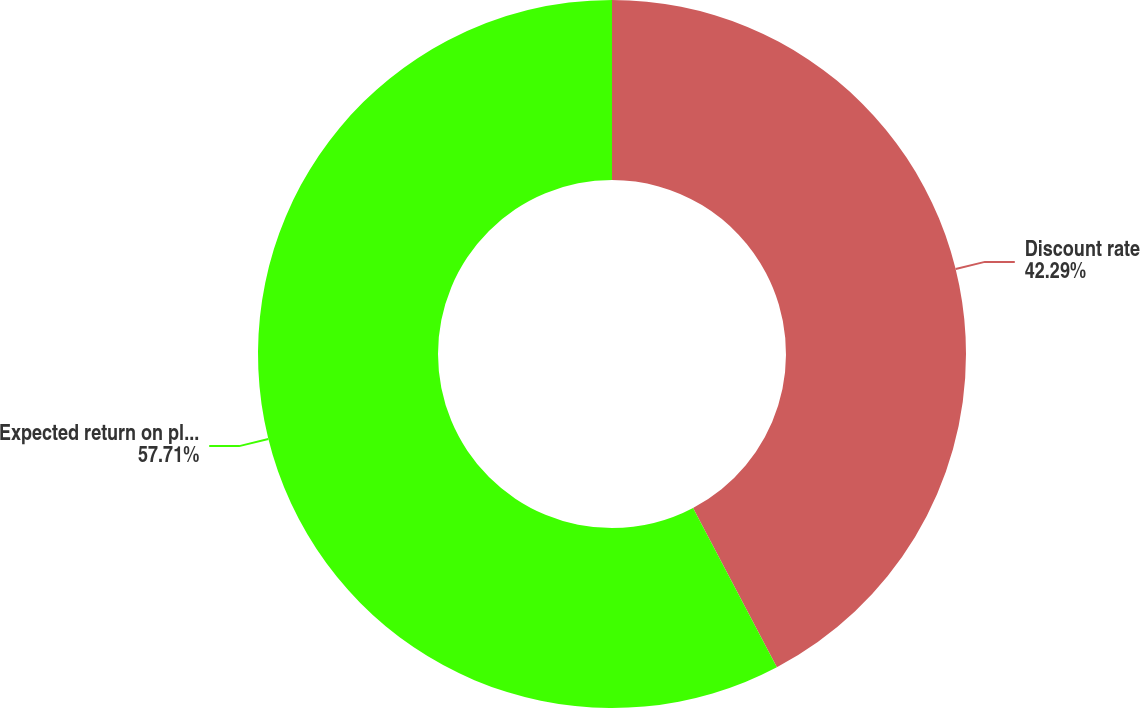<chart> <loc_0><loc_0><loc_500><loc_500><pie_chart><fcel>Discount rate<fcel>Expected return on plan assets<nl><fcel>42.29%<fcel>57.71%<nl></chart> 